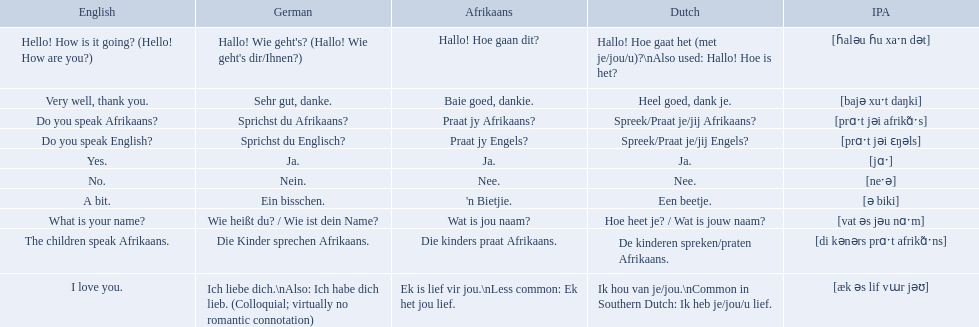How do you say do you speak english in german? Sprichst du Englisch?. What about do you speak afrikaanss? in afrikaans? Praat jy Afrikaans?. 